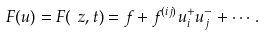Convert formula to latex. <formula><loc_0><loc_0><loc_500><loc_500>F ( u ) = F ( \ z , t ) = f + f ^ { ( i j ) } u _ { i } ^ { + } u _ { j } ^ { - } + \cdots .</formula> 